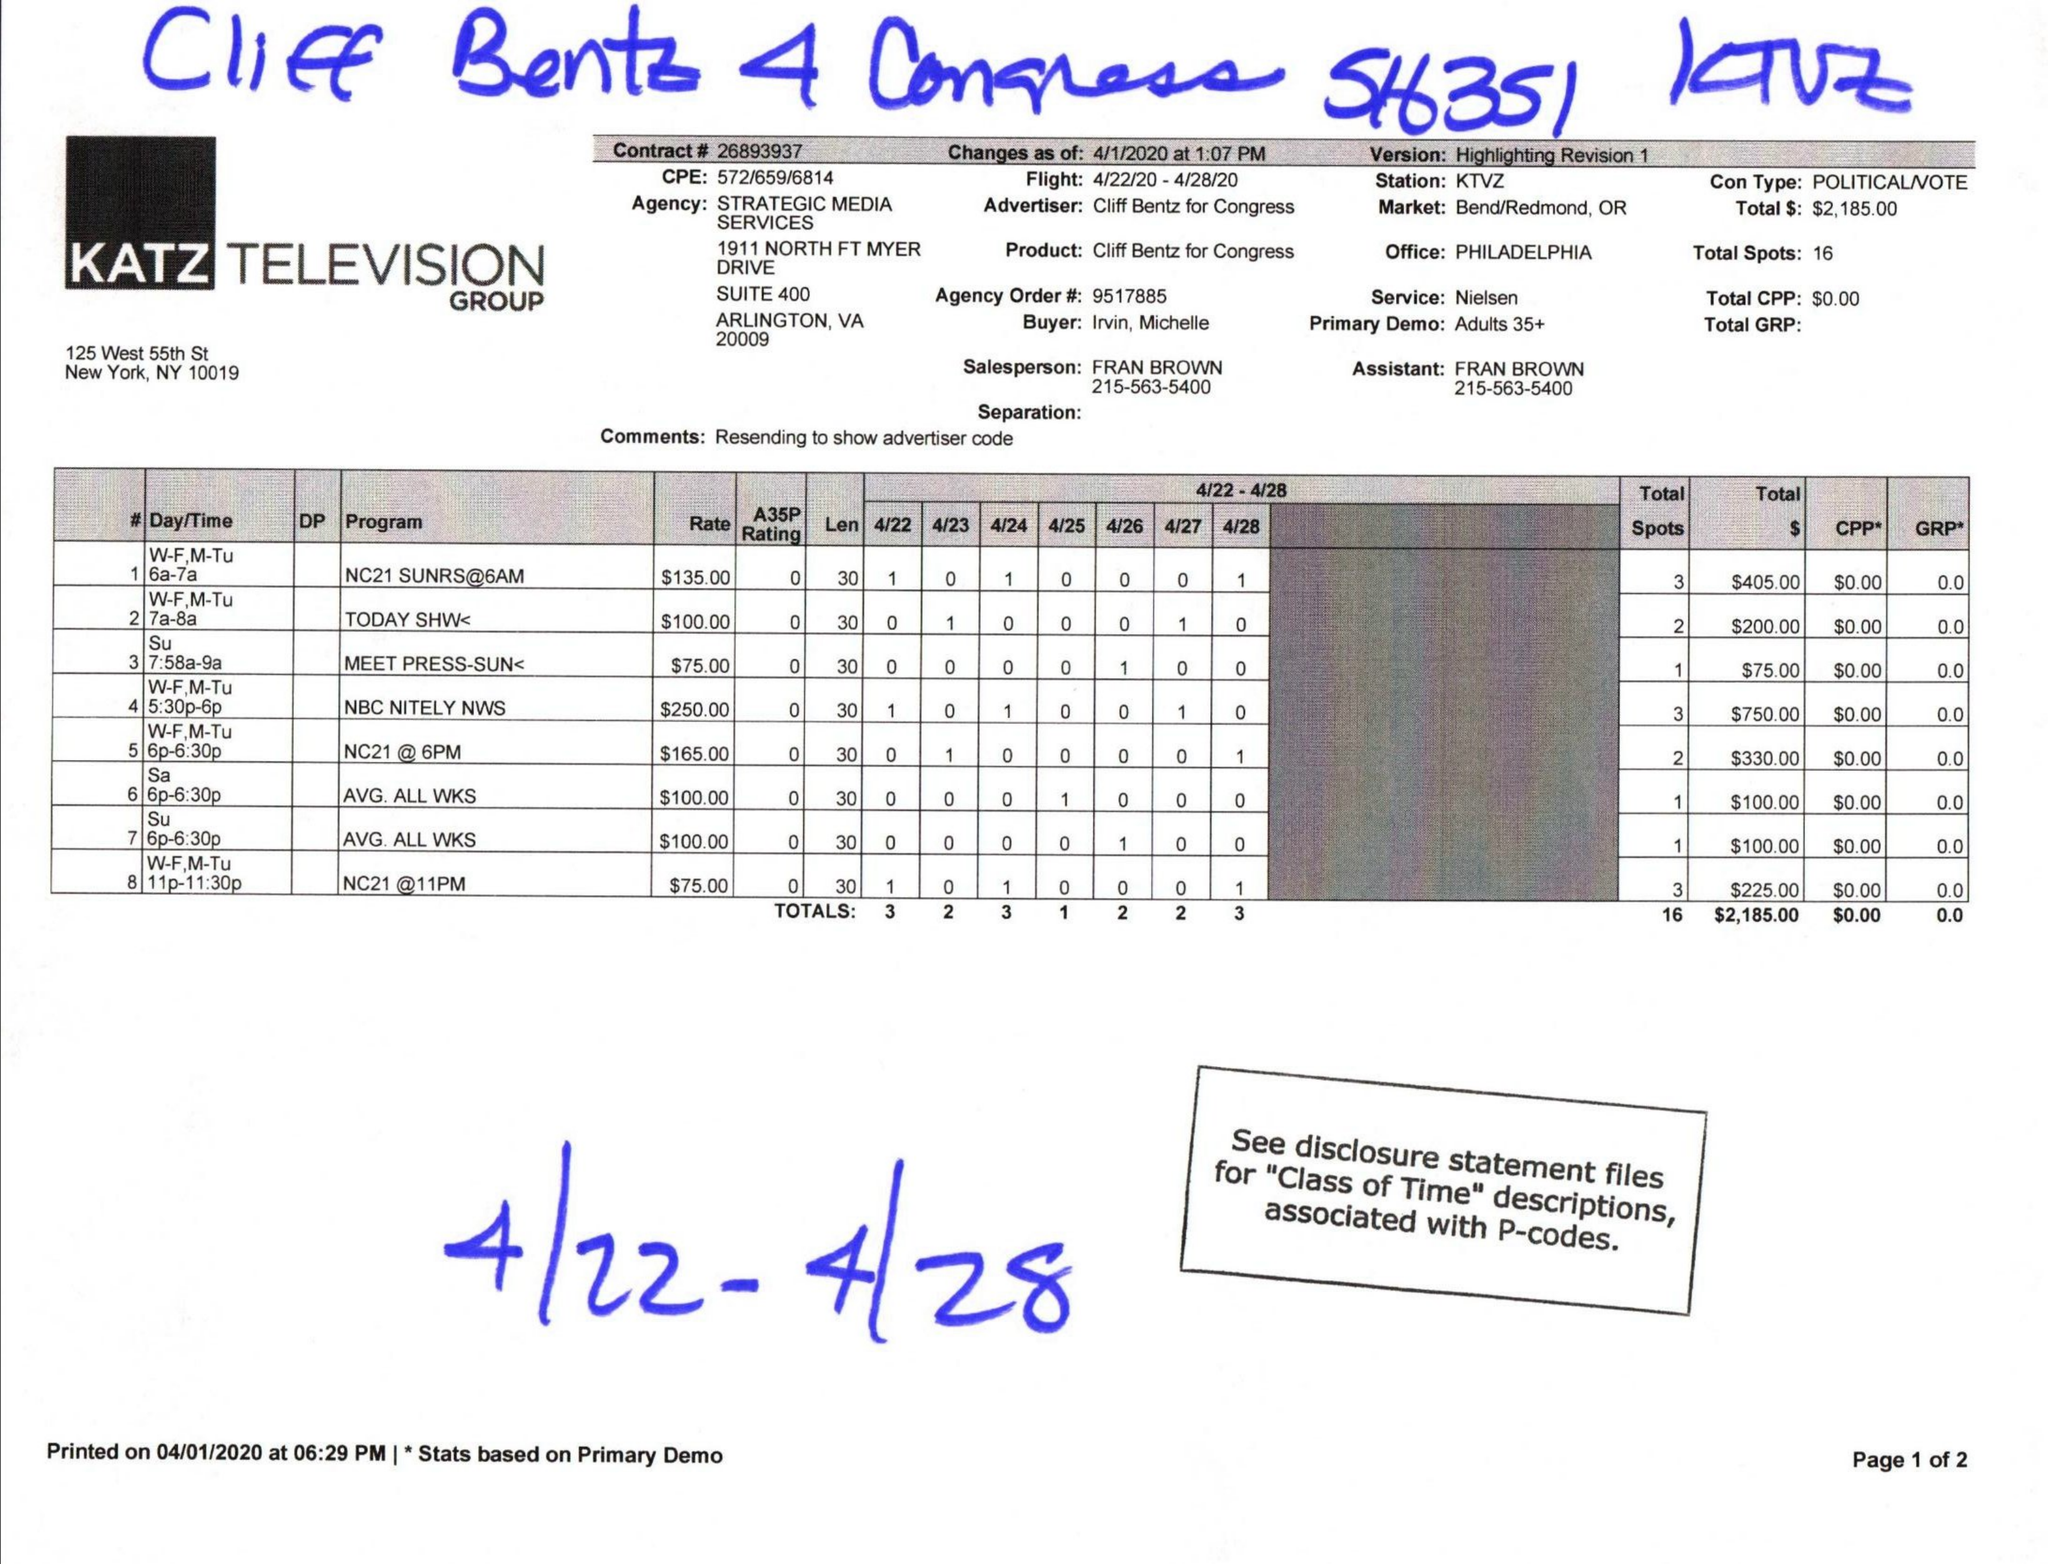What is the value for the gross_amount?
Answer the question using a single word or phrase. 2185.00 